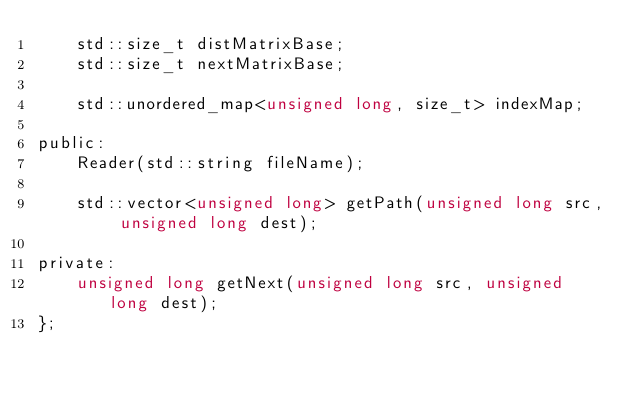<code> <loc_0><loc_0><loc_500><loc_500><_C_>    std::size_t distMatrixBase;
    std::size_t nextMatrixBase;

    std::unordered_map<unsigned long, size_t> indexMap;

public:
    Reader(std::string fileName);

    std::vector<unsigned long> getPath(unsigned long src, unsigned long dest);

private:
    unsigned long getNext(unsigned long src, unsigned long dest);
};</code> 